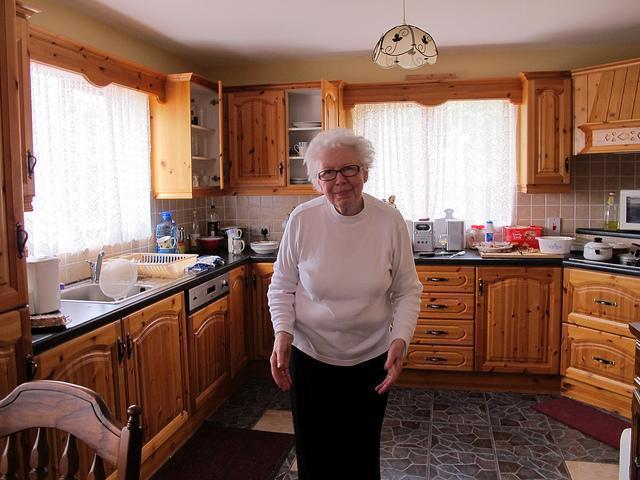Which term would best describe this woman?
From the following four choices, select the correct answer to address the question.
Options: Quadragenarian, tricenarian, quinquagenarian, octogenarian. Octogenarian. 